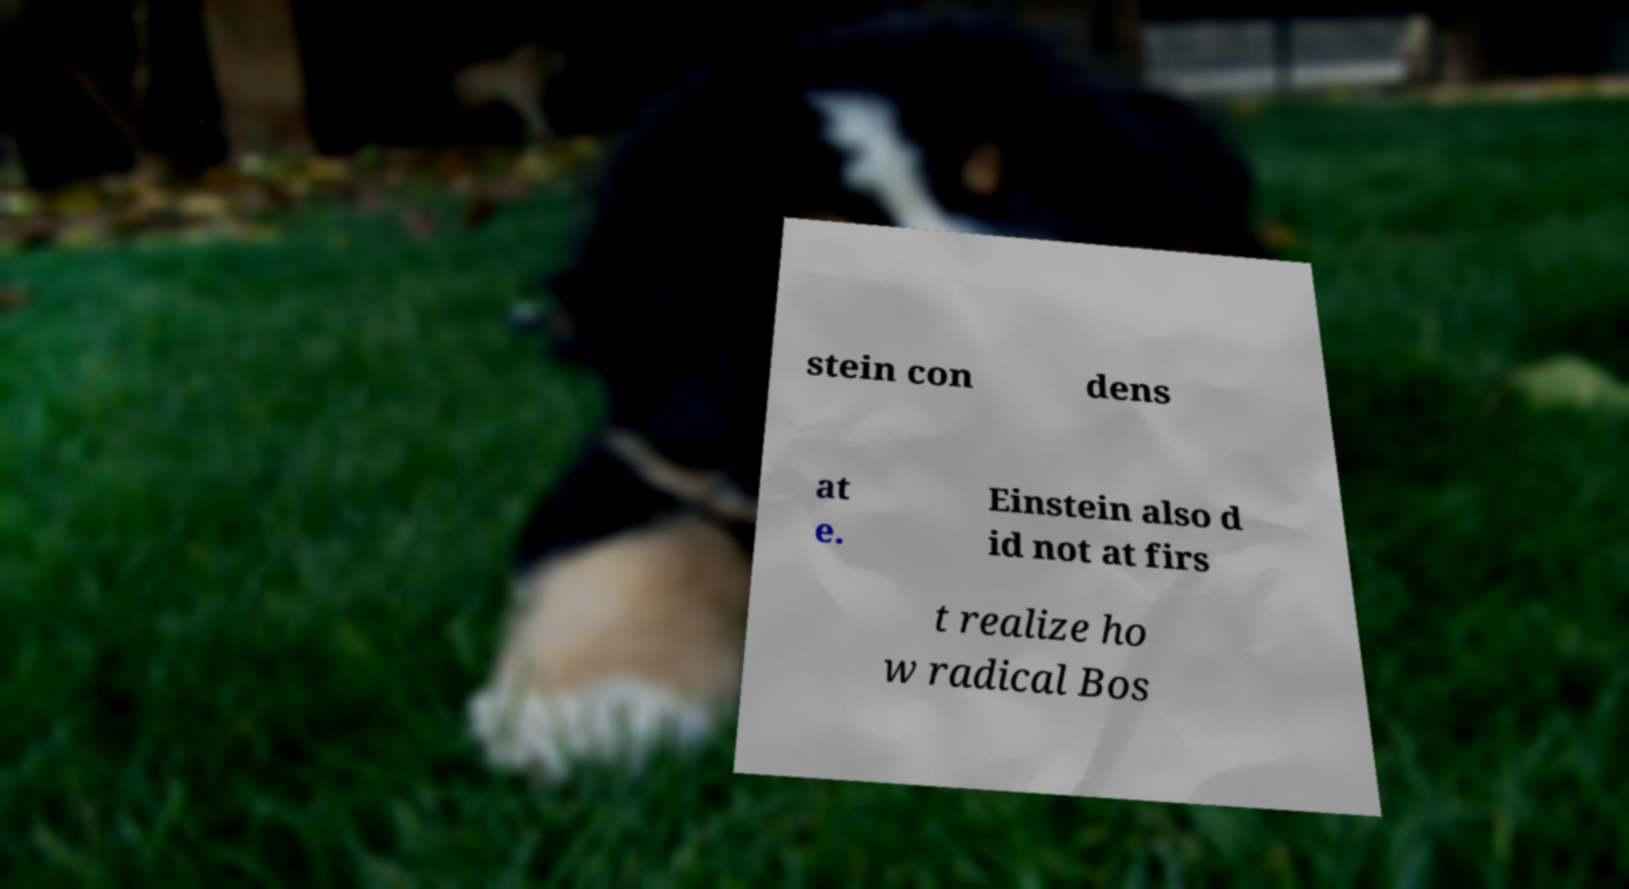For documentation purposes, I need the text within this image transcribed. Could you provide that? stein con dens at e. Einstein also d id not at firs t realize ho w radical Bos 